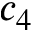Convert formula to latex. <formula><loc_0><loc_0><loc_500><loc_500>c _ { 4 }</formula> 